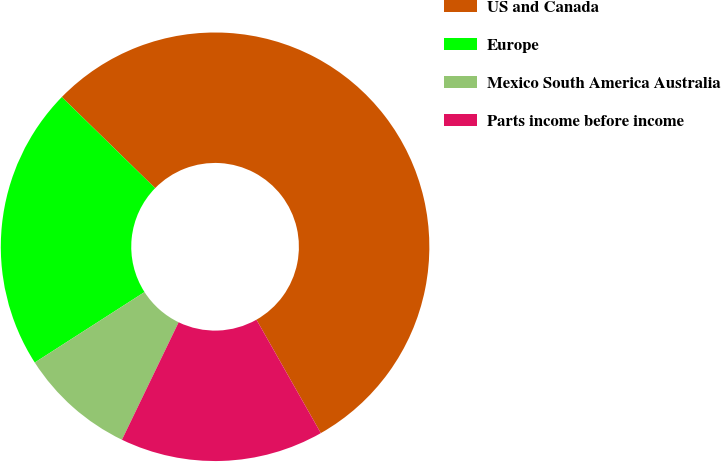Convert chart to OTSL. <chart><loc_0><loc_0><loc_500><loc_500><pie_chart><fcel>US and Canada<fcel>Europe<fcel>Mexico South America Australia<fcel>Parts income before income<nl><fcel>54.47%<fcel>21.4%<fcel>8.76%<fcel>15.37%<nl></chart> 